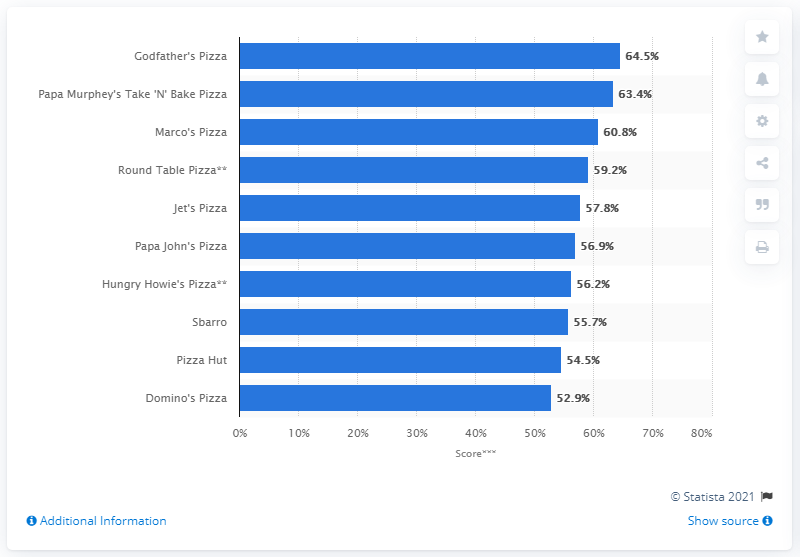Outline some significant characteristics in this image. Godfather's Pizza ranked first in the limited-service pizza segment. 